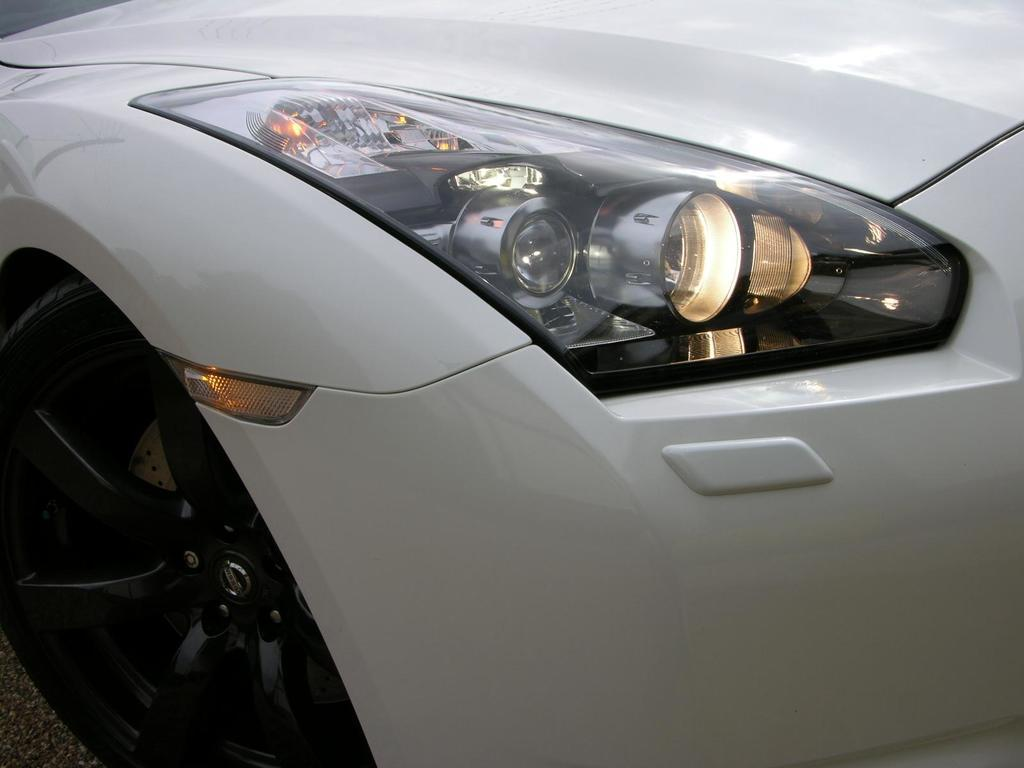What is the main subject of the image? The main subject of the image is a car. Can you describe the car in the image? The image is a zoomed in picture of a car, so specific details about the car cannot be seen. What is visible at the bottom of the image? There is a road visible at the bottom of the image. What type of plantation can be seen in the background of the image? There is no plantation visible in the image; it is a zoomed in picture of a car with a road at the bottom. 